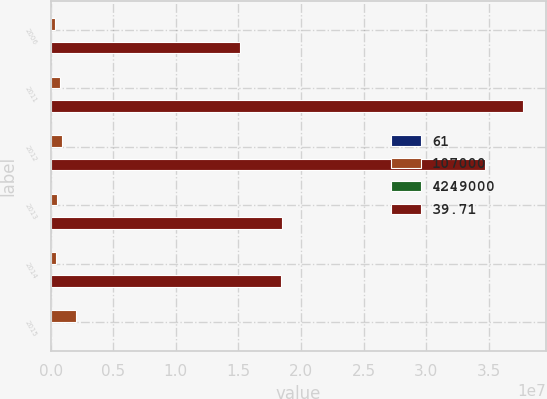Convert chart. <chart><loc_0><loc_0><loc_500><loc_500><stacked_bar_chart><ecel><fcel>2006<fcel>2011<fcel>2012<fcel>2013<fcel>2014<fcel>2015<nl><fcel>61<fcel>85<fcel>40<fcel>38<fcel>20<fcel>37<fcel>43<nl><fcel>107000<fcel>337000<fcel>745000<fcel>920000<fcel>493000<fcel>399000<fcel>2.025e+06<nl><fcel>4.249e+06<fcel>3<fcel>6.6<fcel>8.2<fcel>4.4<fcel>3.6<fcel>18<nl><fcel>39.71<fcel>1.512e+07<fcel>3.7702e+07<fcel>3.4704e+07<fcel>1.8507e+07<fcel>1.8406e+07<fcel>85<nl></chart> 